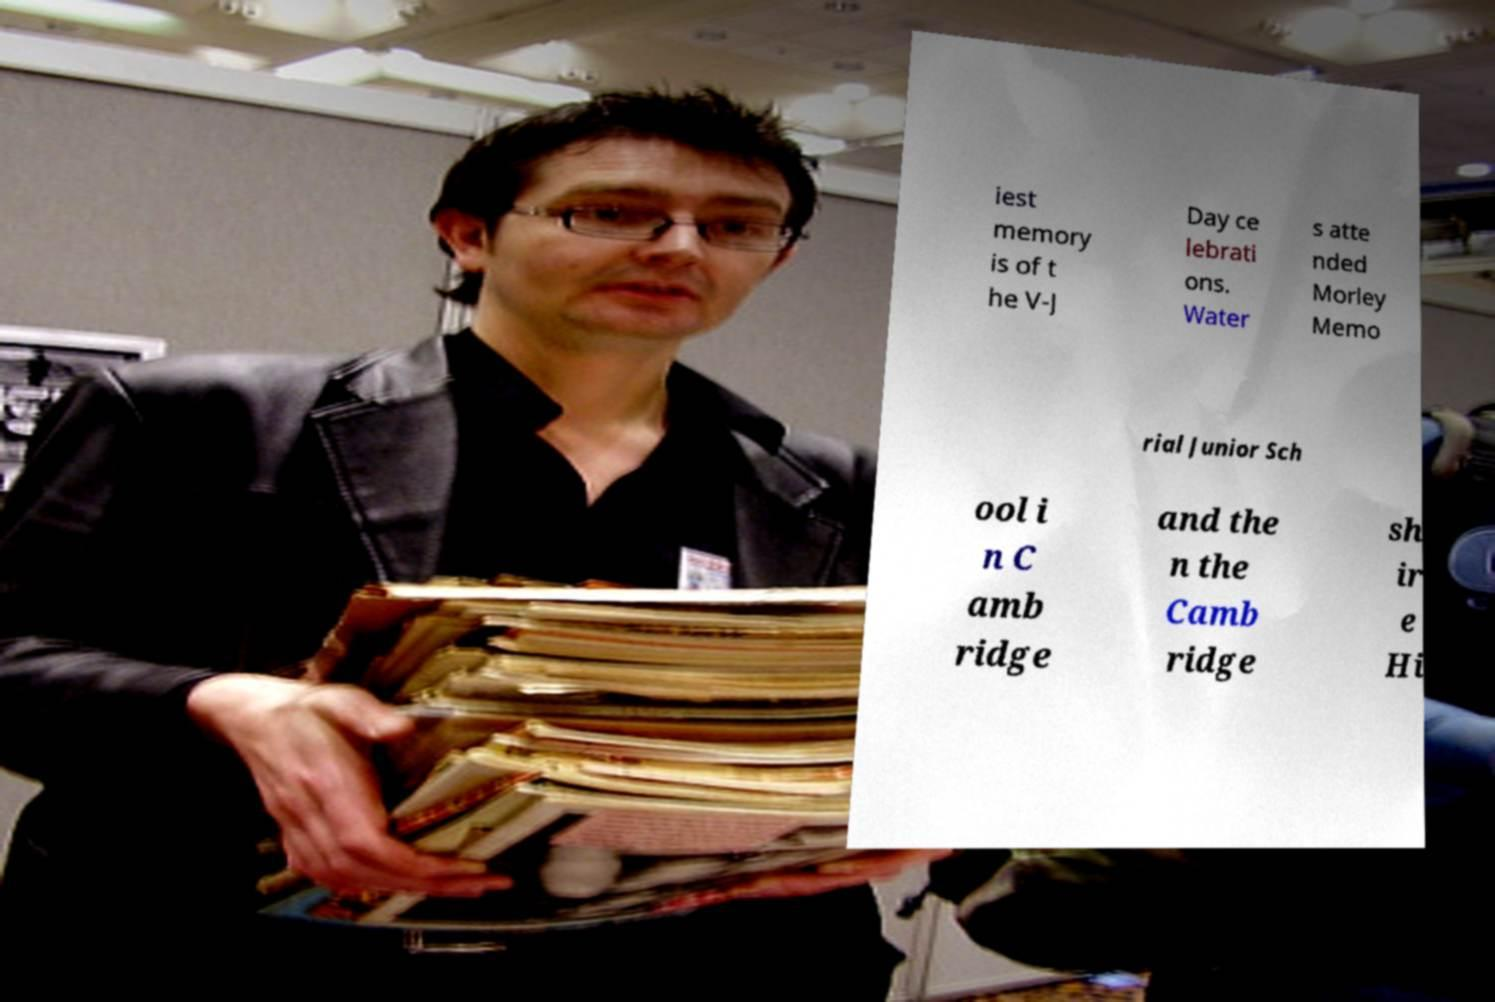Can you accurately transcribe the text from the provided image for me? iest memory is of t he V-J Day ce lebrati ons. Water s atte nded Morley Memo rial Junior Sch ool i n C amb ridge and the n the Camb ridge sh ir e Hi 